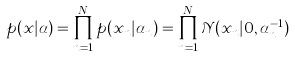<formula> <loc_0><loc_0><loc_500><loc_500>p ( x | \alpha ) = \prod _ { n = 1 } ^ { N } p ( x _ { n } | \alpha _ { n } ) = \prod _ { n = 1 } ^ { N } \mathcal { N } ( x _ { n } | 0 , \alpha _ { n } ^ { - 1 } )</formula> 